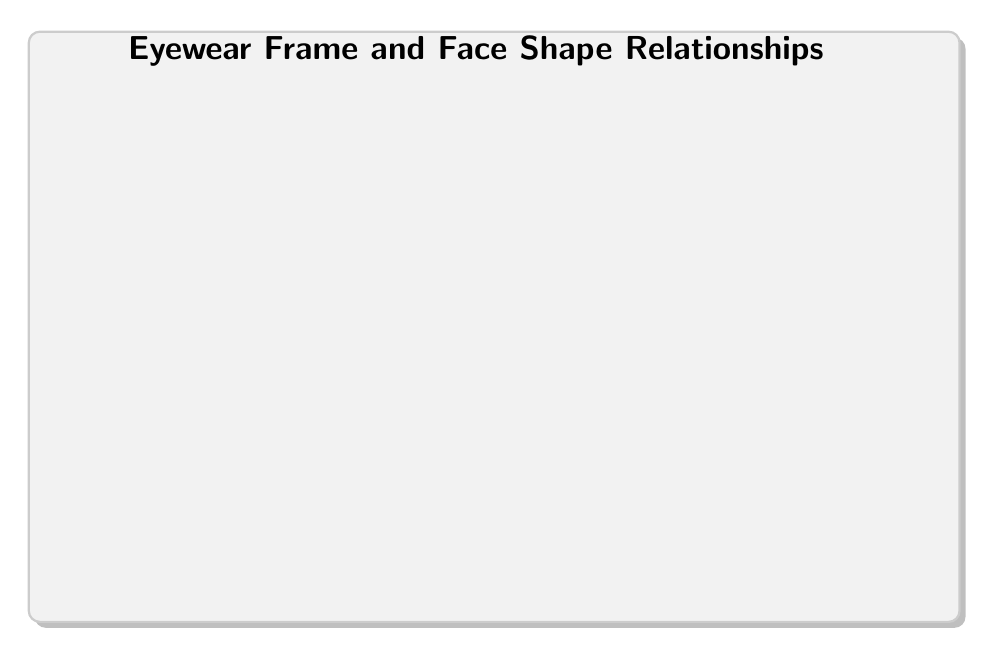What's the value of the link between the Round Frame and the Ovoid Face? The diagram shows a connection between the Round Frame and Ovoid Face, indicated by an arrow labeled with the value 2.
Answer: 2 Which face shape is most compatible with the Cat-Eye Frame? The diagram displays two links originating from the Cat-Eye Frame, with the highest value link pointing to the Heart-Shaped Face, labeled with the value 2.
Answer: Heart-Shaped Face How many nodes represent frame shapes in this diagram? The diagram includes three frame shape nodes: Round Frame, Square Frame, and Cat-Eye Frame. Counting these nodes results in a total of 3 frame shape nodes.
Answer: 3 What is the value of the connection between the Square Frame and the Square Face? The link between the Square Frame and the Square Face is shown with an arrow labeled with the value 2 on the diagram.
Answer: 2 Which frame shape has the least associations with a face shape? By examining the connections, the Round Frame has only two links (to Ovoid Face and Square Face) and has the least associations compared to the others.
Answer: Round Frame How many links are associated with the Cat-Eye Frame? The Cat-Eye Frame has three outgoing links connecting to Ovoid Face, Square Face, and Heart-Shaped Face, indicating three associations.
Answer: 3 Which face shape has the highest value connections overall? The Heart-Shaped Face connects with links valued at 2 from both the Square Frame and Cat-Eye Frame, totaling the highest values associated with it.
Answer: Heart-Shaped Face What is the relationship value between the Square Frame and the Heart-Shaped Face? In the diagram, there is a specific link from Square Frame to Heart-Shaped Face with a value of 1 depicted by the arrow.
Answer: 1 Which frame shape has connections to both Ovoid and Square Face shapes? The Square Frame connects to both the Ovoid Face (value 1) and Square Face (value 2), making it the only frame with links to these two faces.
Answer: Square Frame 